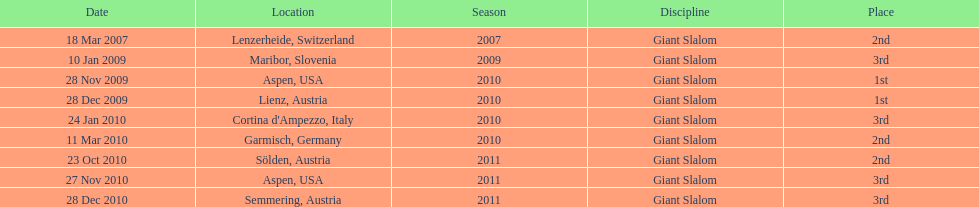How many races were in 2010? 5. 